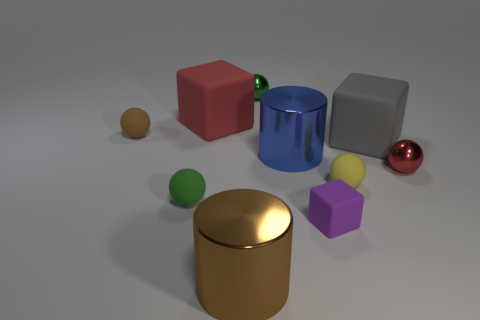Subtract all large rubber cubes. How many cubes are left? 1 Subtract 4 balls. How many balls are left? 1 Subtract all purple cubes. How many cubes are left? 2 Subtract all brown cylinders. Subtract all yellow balls. How many cylinders are left? 1 Subtract all purple balls. How many gray cylinders are left? 0 Subtract 0 yellow cubes. How many objects are left? 10 Subtract all cylinders. How many objects are left? 8 Subtract all blue shiny things. Subtract all blue things. How many objects are left? 8 Add 4 big brown metallic cylinders. How many big brown metallic cylinders are left? 5 Add 3 shiny things. How many shiny things exist? 7 